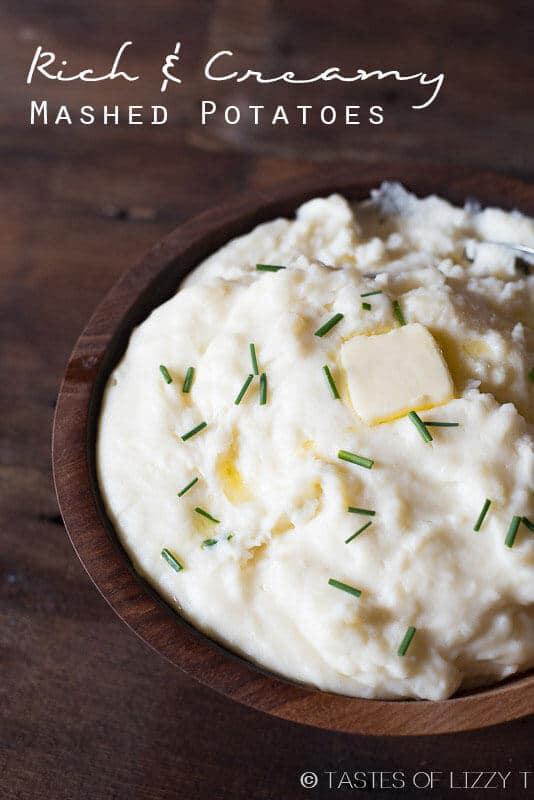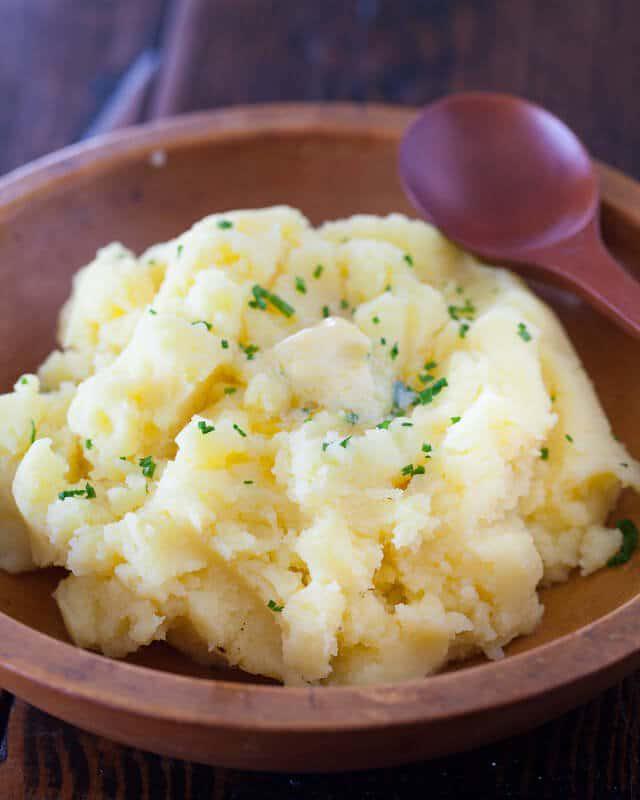The first image is the image on the left, the second image is the image on the right. Considering the images on both sides, is "An image contains mashed potatoes with a spoon inside it." valid? Answer yes or no. No. The first image is the image on the left, the second image is the image on the right. Analyze the images presented: Is the assertion "An unmelted pat of butter sits in the dish in one of the images." valid? Answer yes or no. Yes. 